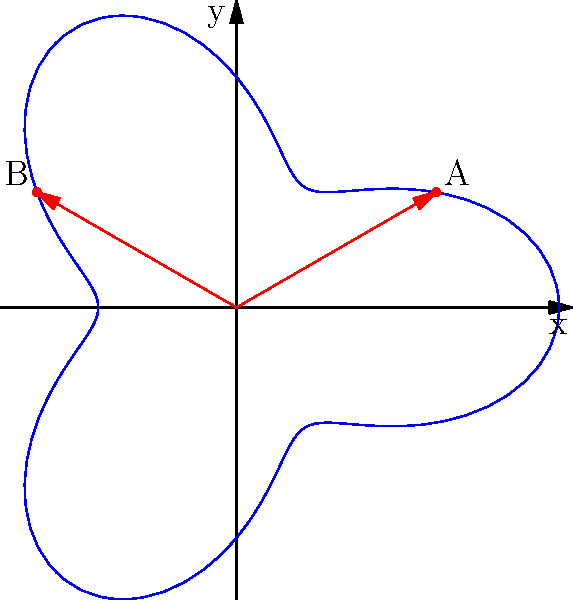In preparation for a gaming tournament, you're analyzing sound wave propagation in a circular auditorium. The auditorium's shape is represented by the polar equation $r = 5 + 2\cos(3\theta)$. Two speakers are placed at points A and B, as shown in the diagram. What is the angular separation between these two speakers? To find the angular separation between the two speakers, we need to:

1. Identify the angles for points A and B:
   Point A: $\theta_1 = \frac{\pi}{6}$
   Point B: $\theta_2 = \frac{5\pi}{6}$

2. Calculate the angular separation by subtracting the smaller angle from the larger:
   $\Delta\theta = \theta_2 - \theta_1$

3. Substitute the values:
   $\Delta\theta = \frac{5\pi}{6} - \frac{\pi}{6}$

4. Simplify:
   $\Delta\theta = \frac{4\pi}{6} = \frac{2\pi}{3}$

5. Convert to degrees (optional):
   $\frac{2\pi}{3} \cdot \frac{180°}{\pi} = 120°$

The angular separation between the two speakers is $\frac{2\pi}{3}$ radians or 120°.
Answer: $\frac{2\pi}{3}$ radians 